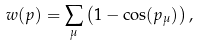Convert formula to latex. <formula><loc_0><loc_0><loc_500><loc_500>w ( p ) = \sum _ { \mu } \left ( 1 - \cos ( p _ { \mu } ) \right ) ,</formula> 